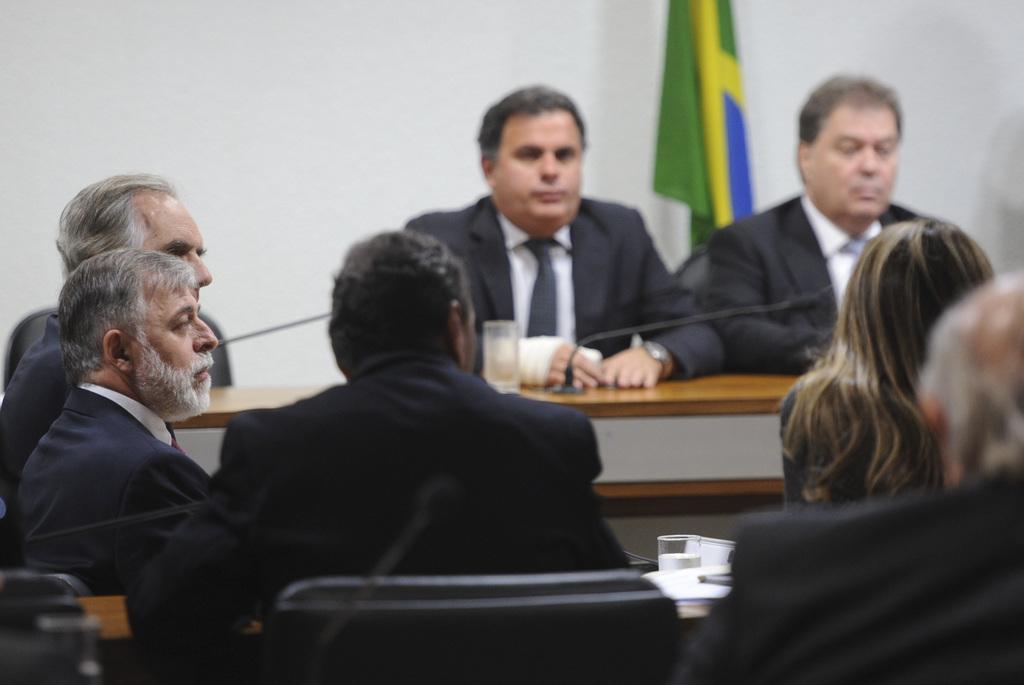Describe this image in one or two sentences. In this picture there are few persons wearing black suits are sitting and there is a table in front of them which has a mic on it. 